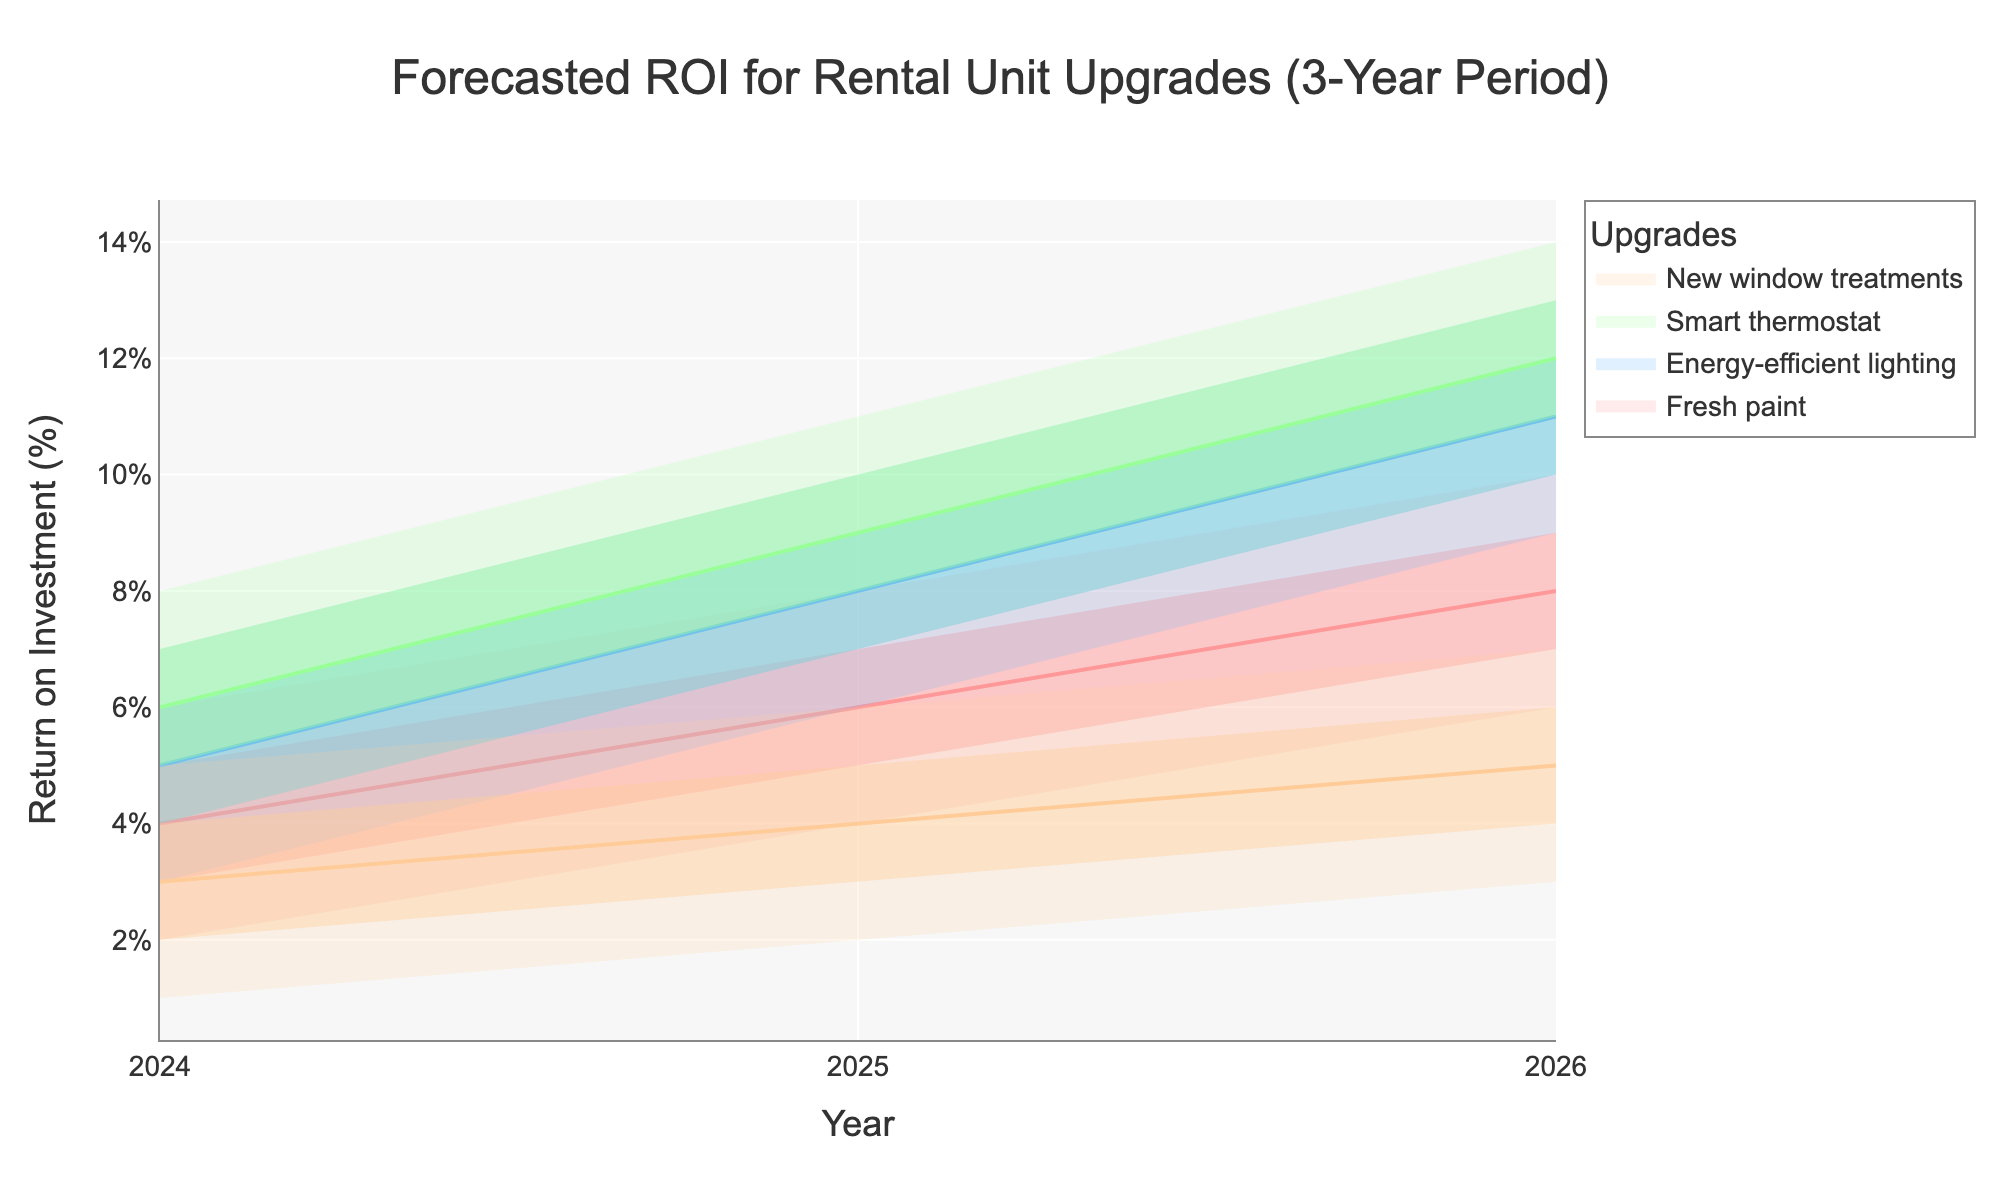What's the title of the figure? The title is usually displayed at the top of the figure. By looking at the rendered figure, you can see the title text.
Answer: Forecasted ROI for Rental Unit Upgrades (3-Year Period) What is the forecasted return on investment for a smart thermostat in 2025 at the Mid-High level? Locate the smart thermostat's Mid-High level for the year 2025 by finding the corresponding data point in the visualization.
Answer: 10% Which upgrade has the lowest forecasted return on investment in 2024? Compare the 'Low' level ROI for all upgrades in 2024 and find the minimum value.
Answer: New window treatments What is the average ROI for Fresh paint from 2024 to 2026 at the Mid level? Sum the Mid values for Fresh paint in 2024, 2025, and 2026, then divide by 3 to find the average. (4 + 6 + 8) / 3
Answer: 6% Which upgrade shows the highest increase in the Mid-Mid forecasted return on investment from 2024 to 2026? Calculate the difference in Mid ROI values from 2024 to 2026 for each upgrade and find the upgrade with the highest increase. Smart thermostat increases by (12 - 6) = 6, while others increase by a smaller amount.
Answer: Smart thermostat Is the forecasted ROI for energy-efficient lighting always higher than that for new window treatments across all years at the Low level? Compare the Low ROI values for energy-efficient lighting and new window treatments for each year. Energy-efficient lighting (3, 6, 9) is always higher than new window treatments (1, 2, 3).
Answer: Yes On average, which upgrade has the highest Mid-High forecasted ROI over the three years? Calculate the average of the Mid-High forecasted ROI for each upgrade over the three years, then compare these averages. Smart thermostat: (7+10+13)/3 = 10, which is the highest.
Answer: Smart thermostat What is the range of the forecasted ROI for new window treatments in 2026 at all levels? The range is the difference between the highest and lowest forecasted ROI values in 2026: 7 - 3.
Answer: 4% How does the forecasted ROI for energy-efficient lighting change from 2024 to 2025 at the Low-Mid level? Subtract the Low-Mid value in 2024 from that in 2025 for energy-efficient lighting: 7 - 4.
Answer: Increases by 3% Which upgrade has the smallest variation in forecasted ROI from the Low to High level in any given year? Variation can be determined by calculating the difference between Low and High levels for each upgrade in any year. New window treatments in 2024: 5 - 1 = 4, which is the smallest variation among all years and upgrades.
Answer: New window treatments in 2024 